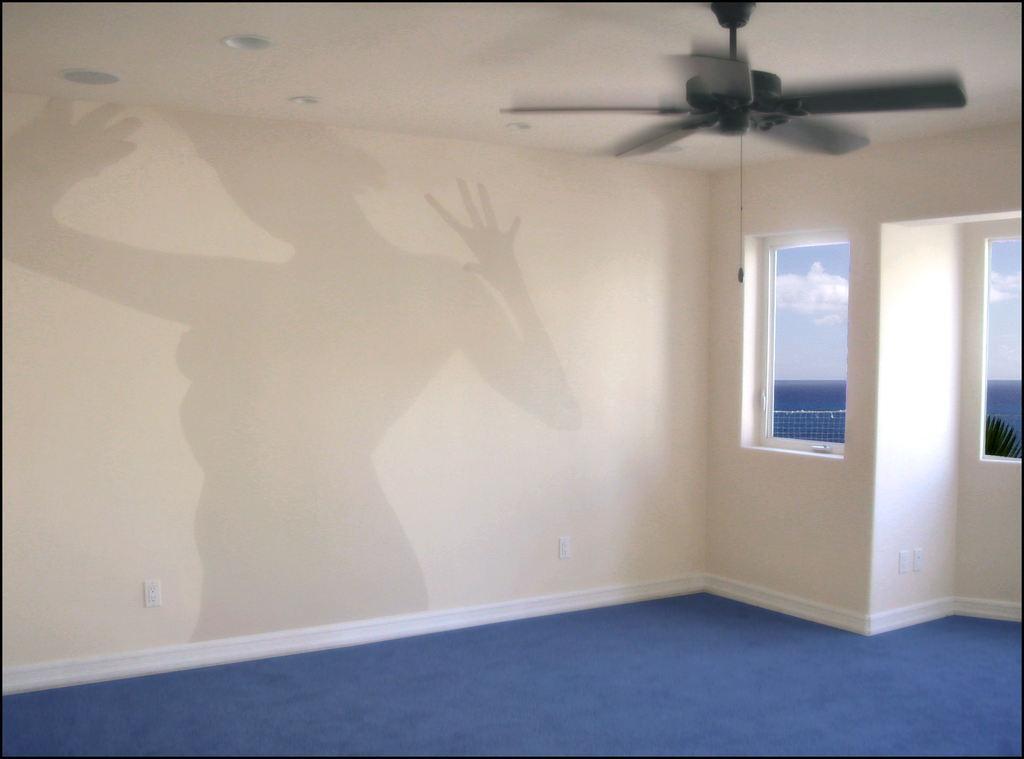Please provide a concise description of this image. In this image, we can see a shadow on the wall. There are windows on the right side of the image. There is a ceiling fan in the top right of the image. 